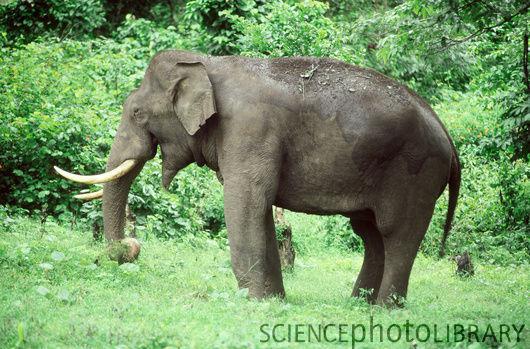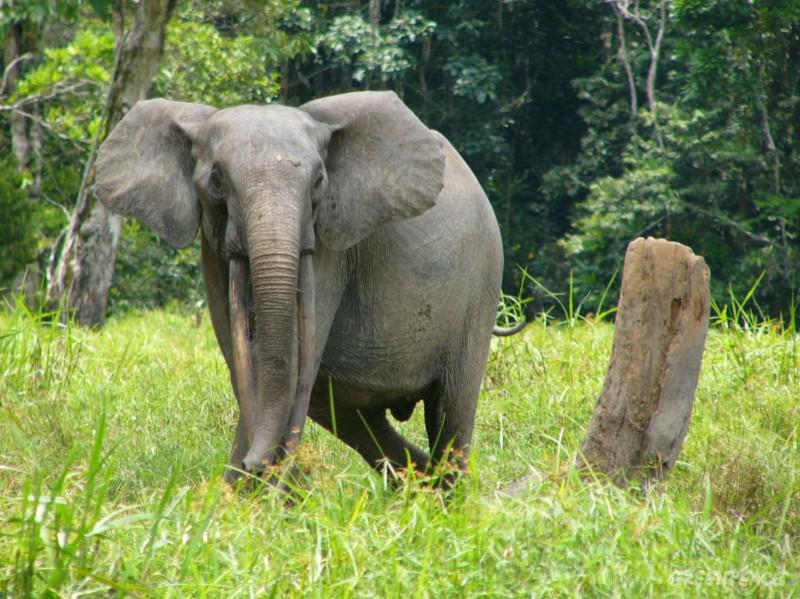The first image is the image on the left, the second image is the image on the right. Given the left and right images, does the statement "There are more elephants in the image on the left." hold true? Answer yes or no. No. The first image is the image on the left, the second image is the image on the right. Examine the images to the left and right. Is the description "There is one elephant in each image." accurate? Answer yes or no. Yes. 